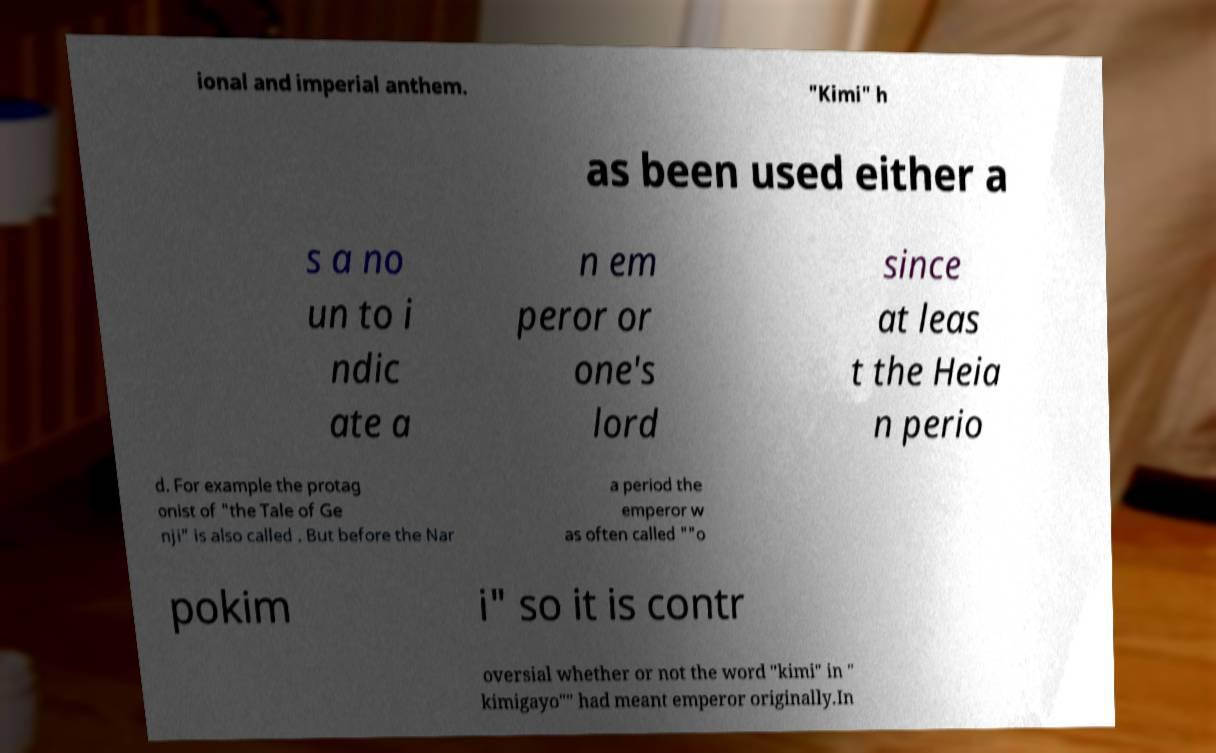For documentation purposes, I need the text within this image transcribed. Could you provide that? ional and imperial anthem. "Kimi" h as been used either a s a no un to i ndic ate a n em peror or one's lord since at leas t the Heia n perio d. For example the protag onist of "the Tale of Ge nji" is also called . But before the Nar a period the emperor w as often called ""o pokim i" so it is contr oversial whether or not the word "kimi" in " kimigayo"" had meant emperor originally.In 